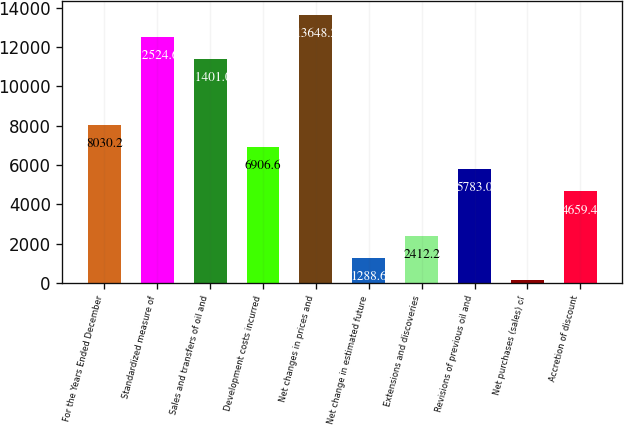Convert chart. <chart><loc_0><loc_0><loc_500><loc_500><bar_chart><fcel>For the Years Ended December<fcel>Standardized measure of<fcel>Sales and transfers of oil and<fcel>Development costs incurred<fcel>Net changes in prices and<fcel>Net change in estimated future<fcel>Extensions and discoveries<fcel>Revisions of previous oil and<fcel>Net purchases (sales) of<fcel>Accretion of discount<nl><fcel>8030.2<fcel>12524.6<fcel>11401<fcel>6906.6<fcel>13648.2<fcel>1288.6<fcel>2412.2<fcel>5783<fcel>165<fcel>4659.4<nl></chart> 